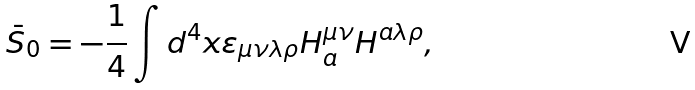Convert formula to latex. <formula><loc_0><loc_0><loc_500><loc_500>\bar { S } _ { 0 } = - \frac { 1 } { 4 } \int d ^ { 4 } x \varepsilon _ { \mu \nu \lambda \rho } H _ { a } ^ { \mu \nu } H ^ { a \lambda \rho } ,</formula> 